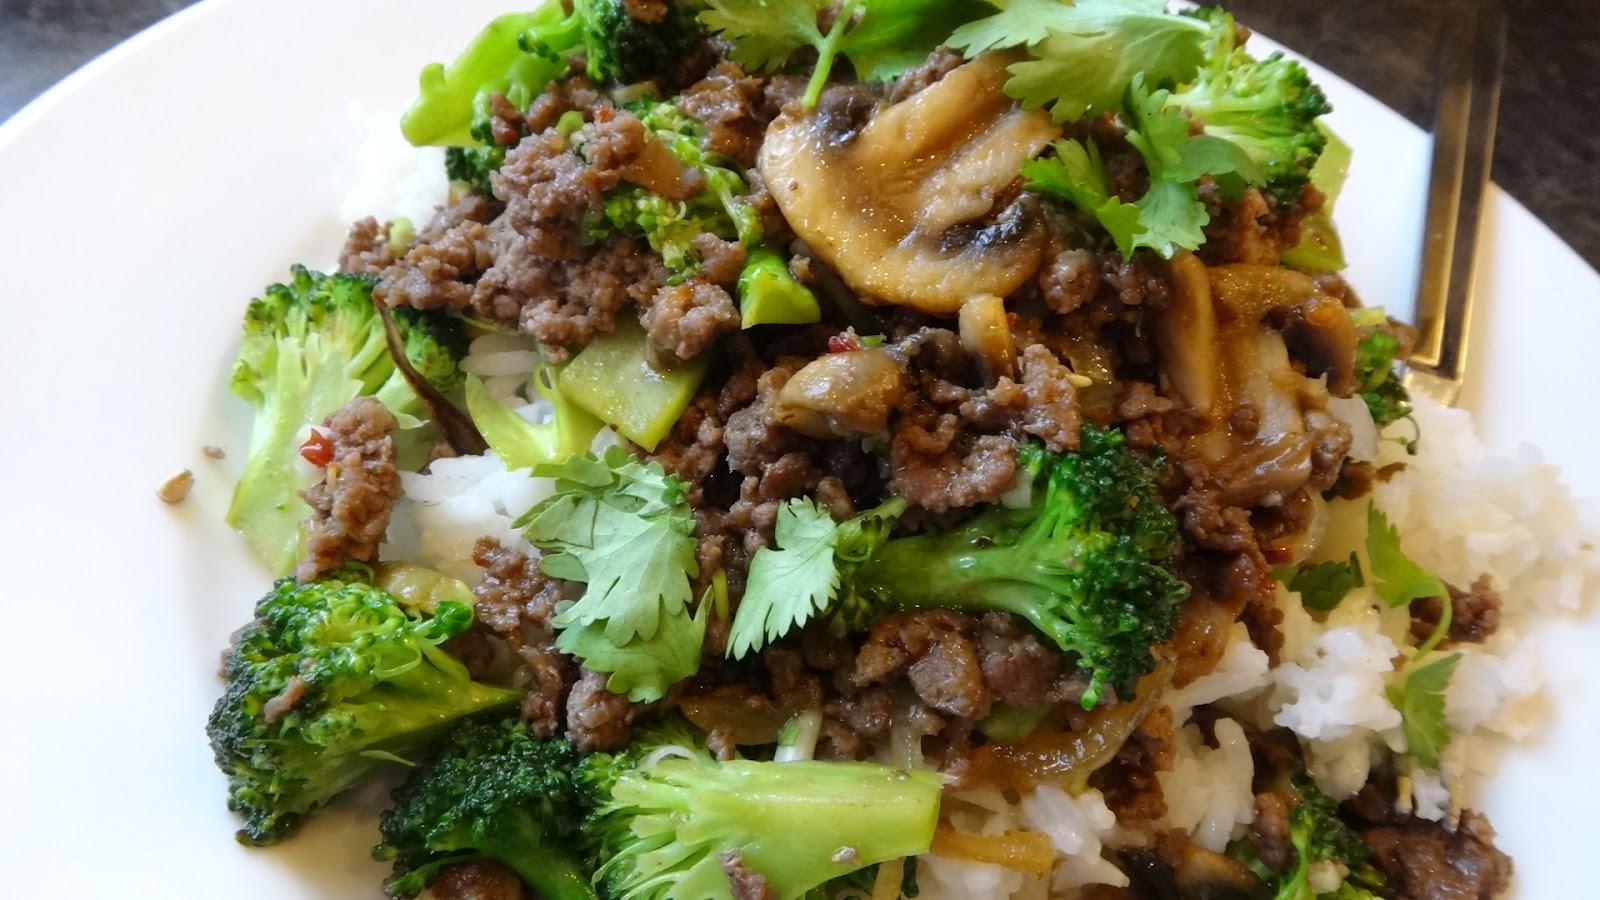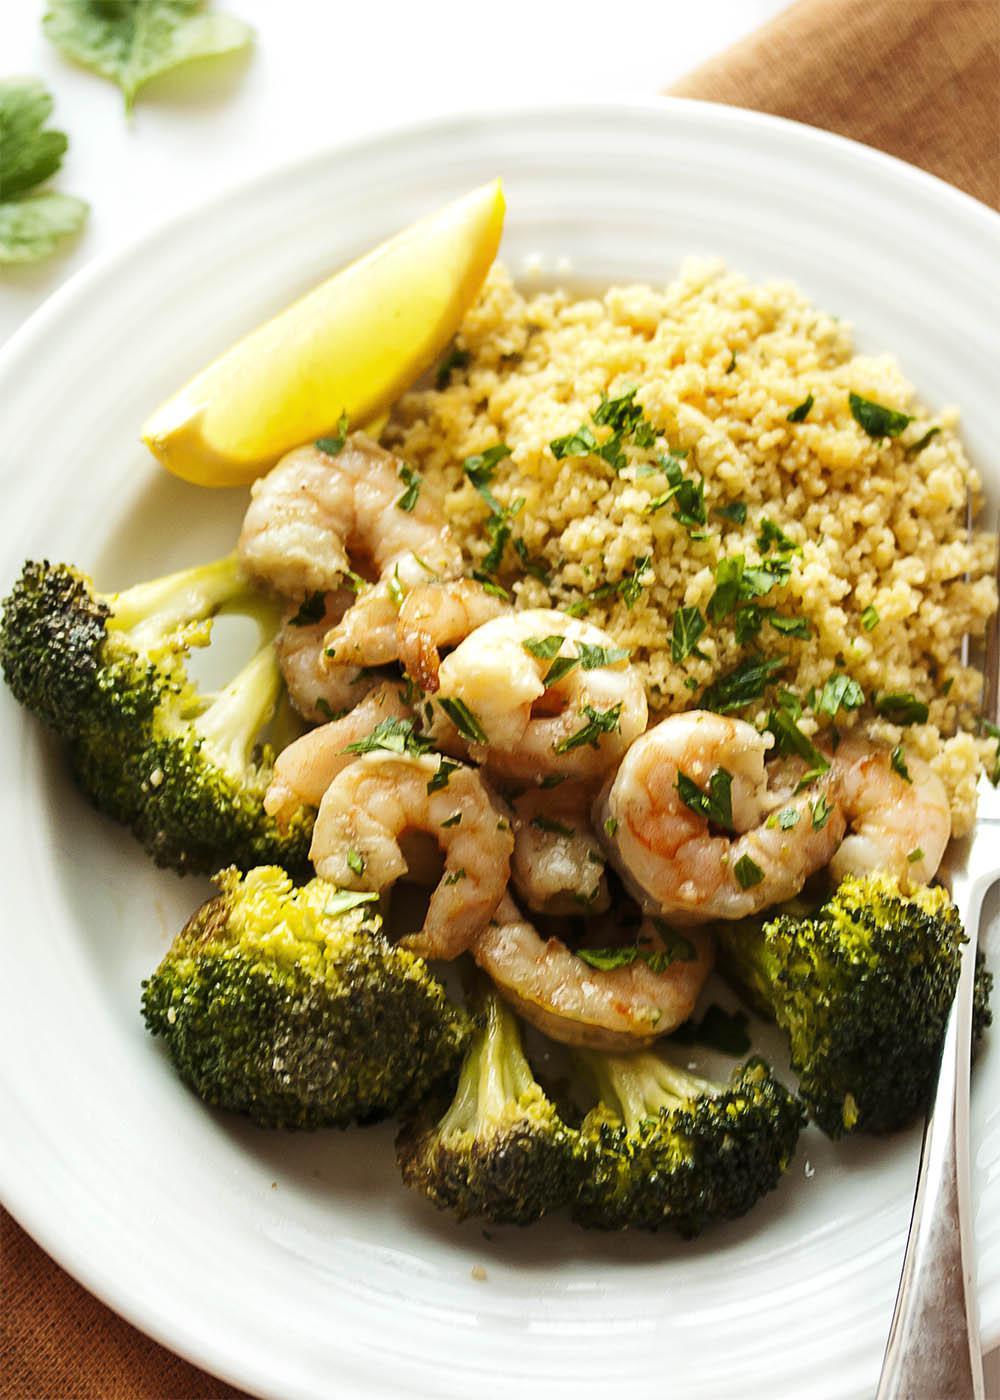The first image is the image on the left, the second image is the image on the right. Analyze the images presented: Is the assertion "One image shows a casserole with a wooden serving spoon, and the other image is at least one individual serving of casserole in a white bowl." valid? Answer yes or no. No. The first image is the image on the left, the second image is the image on the right. Given the left and right images, does the statement "A wooden spoon sits in a container of food." hold true? Answer yes or no. No. 